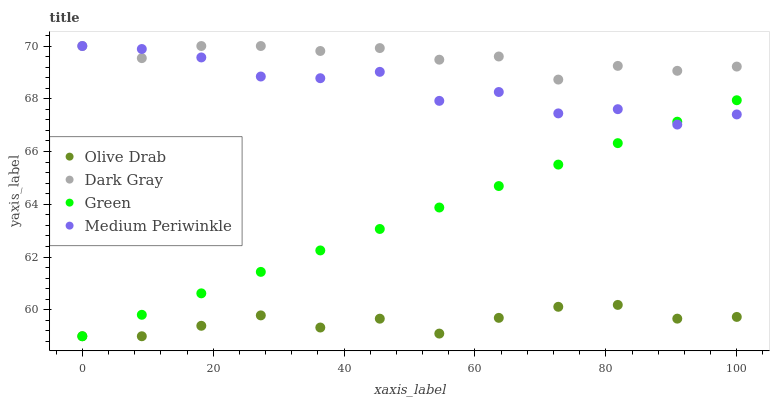Does Olive Drab have the minimum area under the curve?
Answer yes or no. Yes. Does Dark Gray have the maximum area under the curve?
Answer yes or no. Yes. Does Medium Periwinkle have the minimum area under the curve?
Answer yes or no. No. Does Medium Periwinkle have the maximum area under the curve?
Answer yes or no. No. Is Green the smoothest?
Answer yes or no. Yes. Is Medium Periwinkle the roughest?
Answer yes or no. Yes. Is Medium Periwinkle the smoothest?
Answer yes or no. No. Is Green the roughest?
Answer yes or no. No. Does Green have the lowest value?
Answer yes or no. Yes. Does Medium Periwinkle have the lowest value?
Answer yes or no. No. Does Medium Periwinkle have the highest value?
Answer yes or no. Yes. Does Green have the highest value?
Answer yes or no. No. Is Olive Drab less than Dark Gray?
Answer yes or no. Yes. Is Dark Gray greater than Green?
Answer yes or no. Yes. Does Green intersect Medium Periwinkle?
Answer yes or no. Yes. Is Green less than Medium Periwinkle?
Answer yes or no. No. Is Green greater than Medium Periwinkle?
Answer yes or no. No. Does Olive Drab intersect Dark Gray?
Answer yes or no. No. 